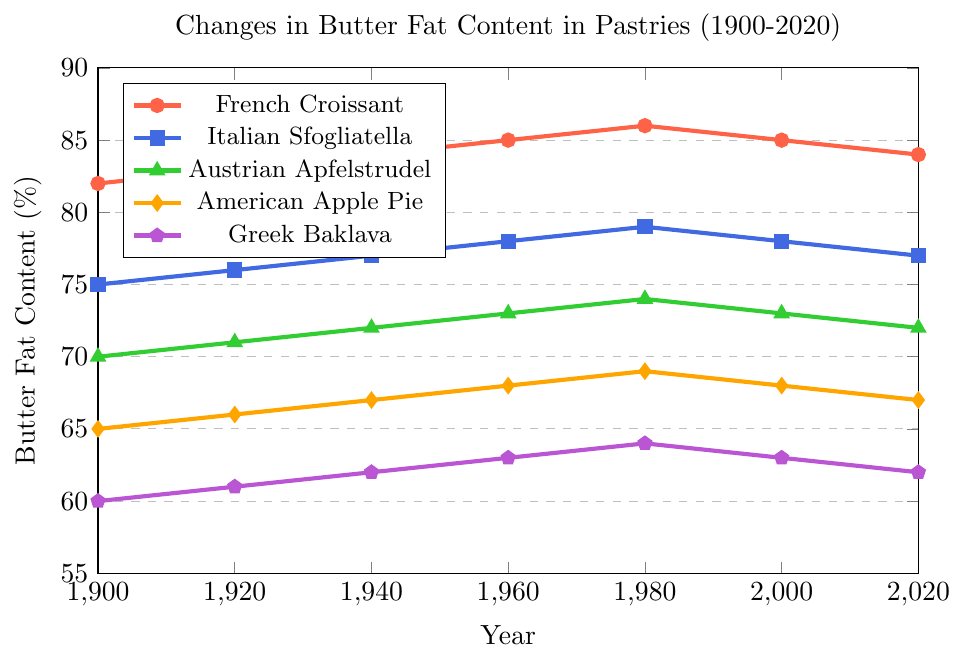What is the butter fat content trend in French Croissant between 1900 and 2020? To determine the trend, observe the data points for French Croissant from 1900 to 2020. The content increased from 82% in 1900 to 86% in 1980, then slightly decreased to 84% in 2020. Thus, the trend shows an initial increase followed by a slight decline.
Answer: Increase then decrease Which pastry had the lowest butter fat content in 1980? Examine the 1980 data points for all pastries. Greek Baklava had the lowest butter fat content at 64%.
Answer: Greek Baklava What was the rate of increase in butter fat content for Austrian Apfelstrudel from 1900 to 1980? Calculate the increase rate: (Butter Fat in 1980 - Butter Fat in 1900) / (1980 - 1900) = (74 - 70) / (1980 - 1900) = 4 / 80 = 0.05% per year.
Answer: 0.05% per year How much did the butter fat content of Italian Sfogliatella change from 2000 to 2020? Compare the values in 2000 (78%) and 2020 (77%). The change is 78% - 77% = 1%.
Answer: Decreased by 1% If the total butter fat content for all pastries in 1920 is summed up, what would be the aggregate value? Sum the butter fat content in 1920 for all pastries: 83 (French Croissant) + 76 (Italian Sfogliatella) + 71 (Austrian Apfelstrudel) + 66 (American Apple Pie) + 61 (Greek Baklava) = 357%.
Answer: 357% What is the average butter fat content for American Apple Pie across all given years? Sum the values and divide by the number of years: (65 + 66 + 67 + 68 + 69 + 68 + 67) / 7 = 470 / 7 ≈ 67.14%.
Answer: 67.14% Which color line represents the French Croissant in the plot? The French Croissant is represented by the red line as indicated in the legend.
Answer: Red 